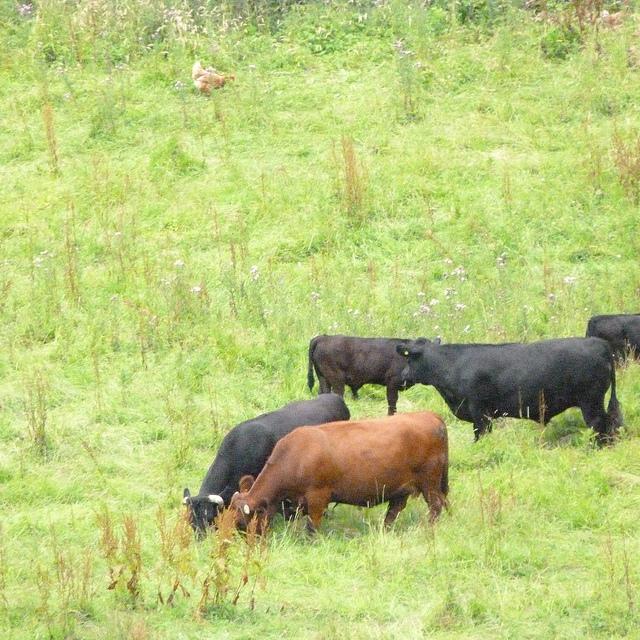Are these bulls located in grass?
Quick response, please. Yes. What color is the Odd Bull?
Quick response, please. Brown. Is the grass lush or dry?
Quick response, please. Lush. 